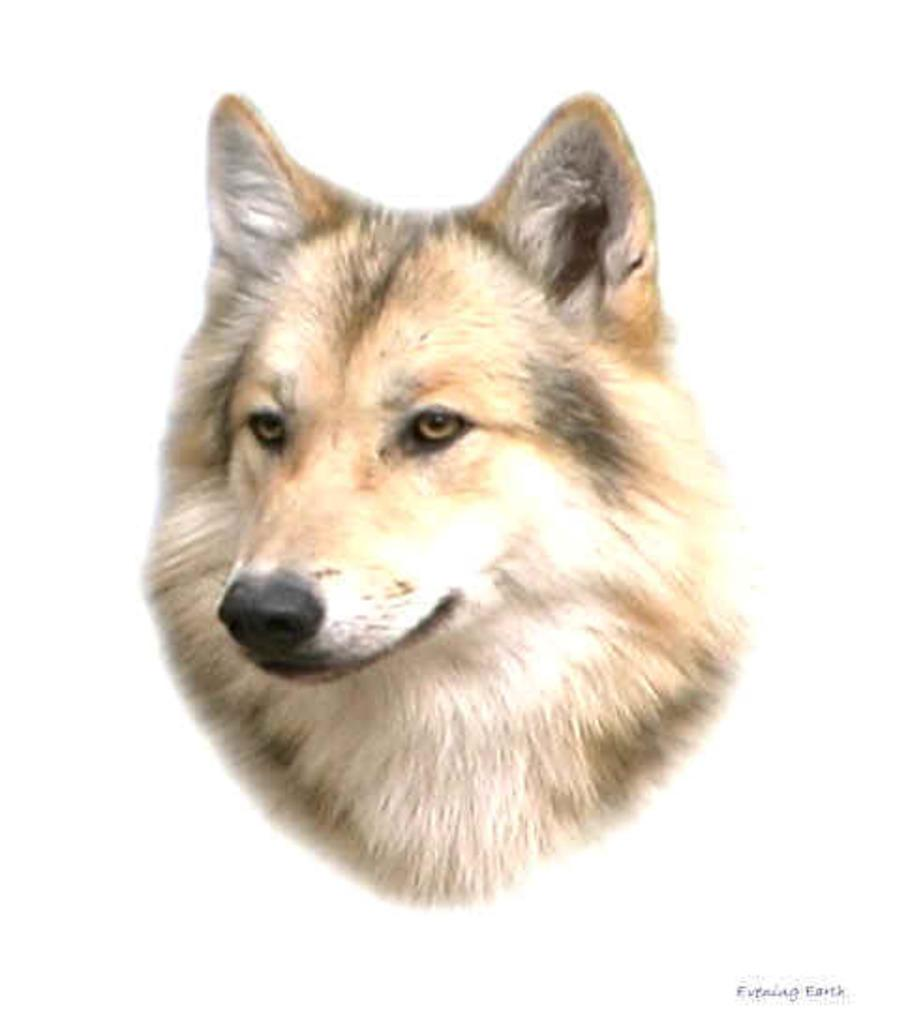What has been done to the image? The image has been edited. What can be seen in the edited image? There is an animal face in the image. Is there any additional information or branding on the image? Yes, there is a watermark on the image. What type of door can be seen in the image? There is no door present in the image; it features an edited animal face and a watermark. What type of stew is being prepared in the image? There is no stew or cooking activity depicted in the image; it only contains an edited animal face and a watermark. 